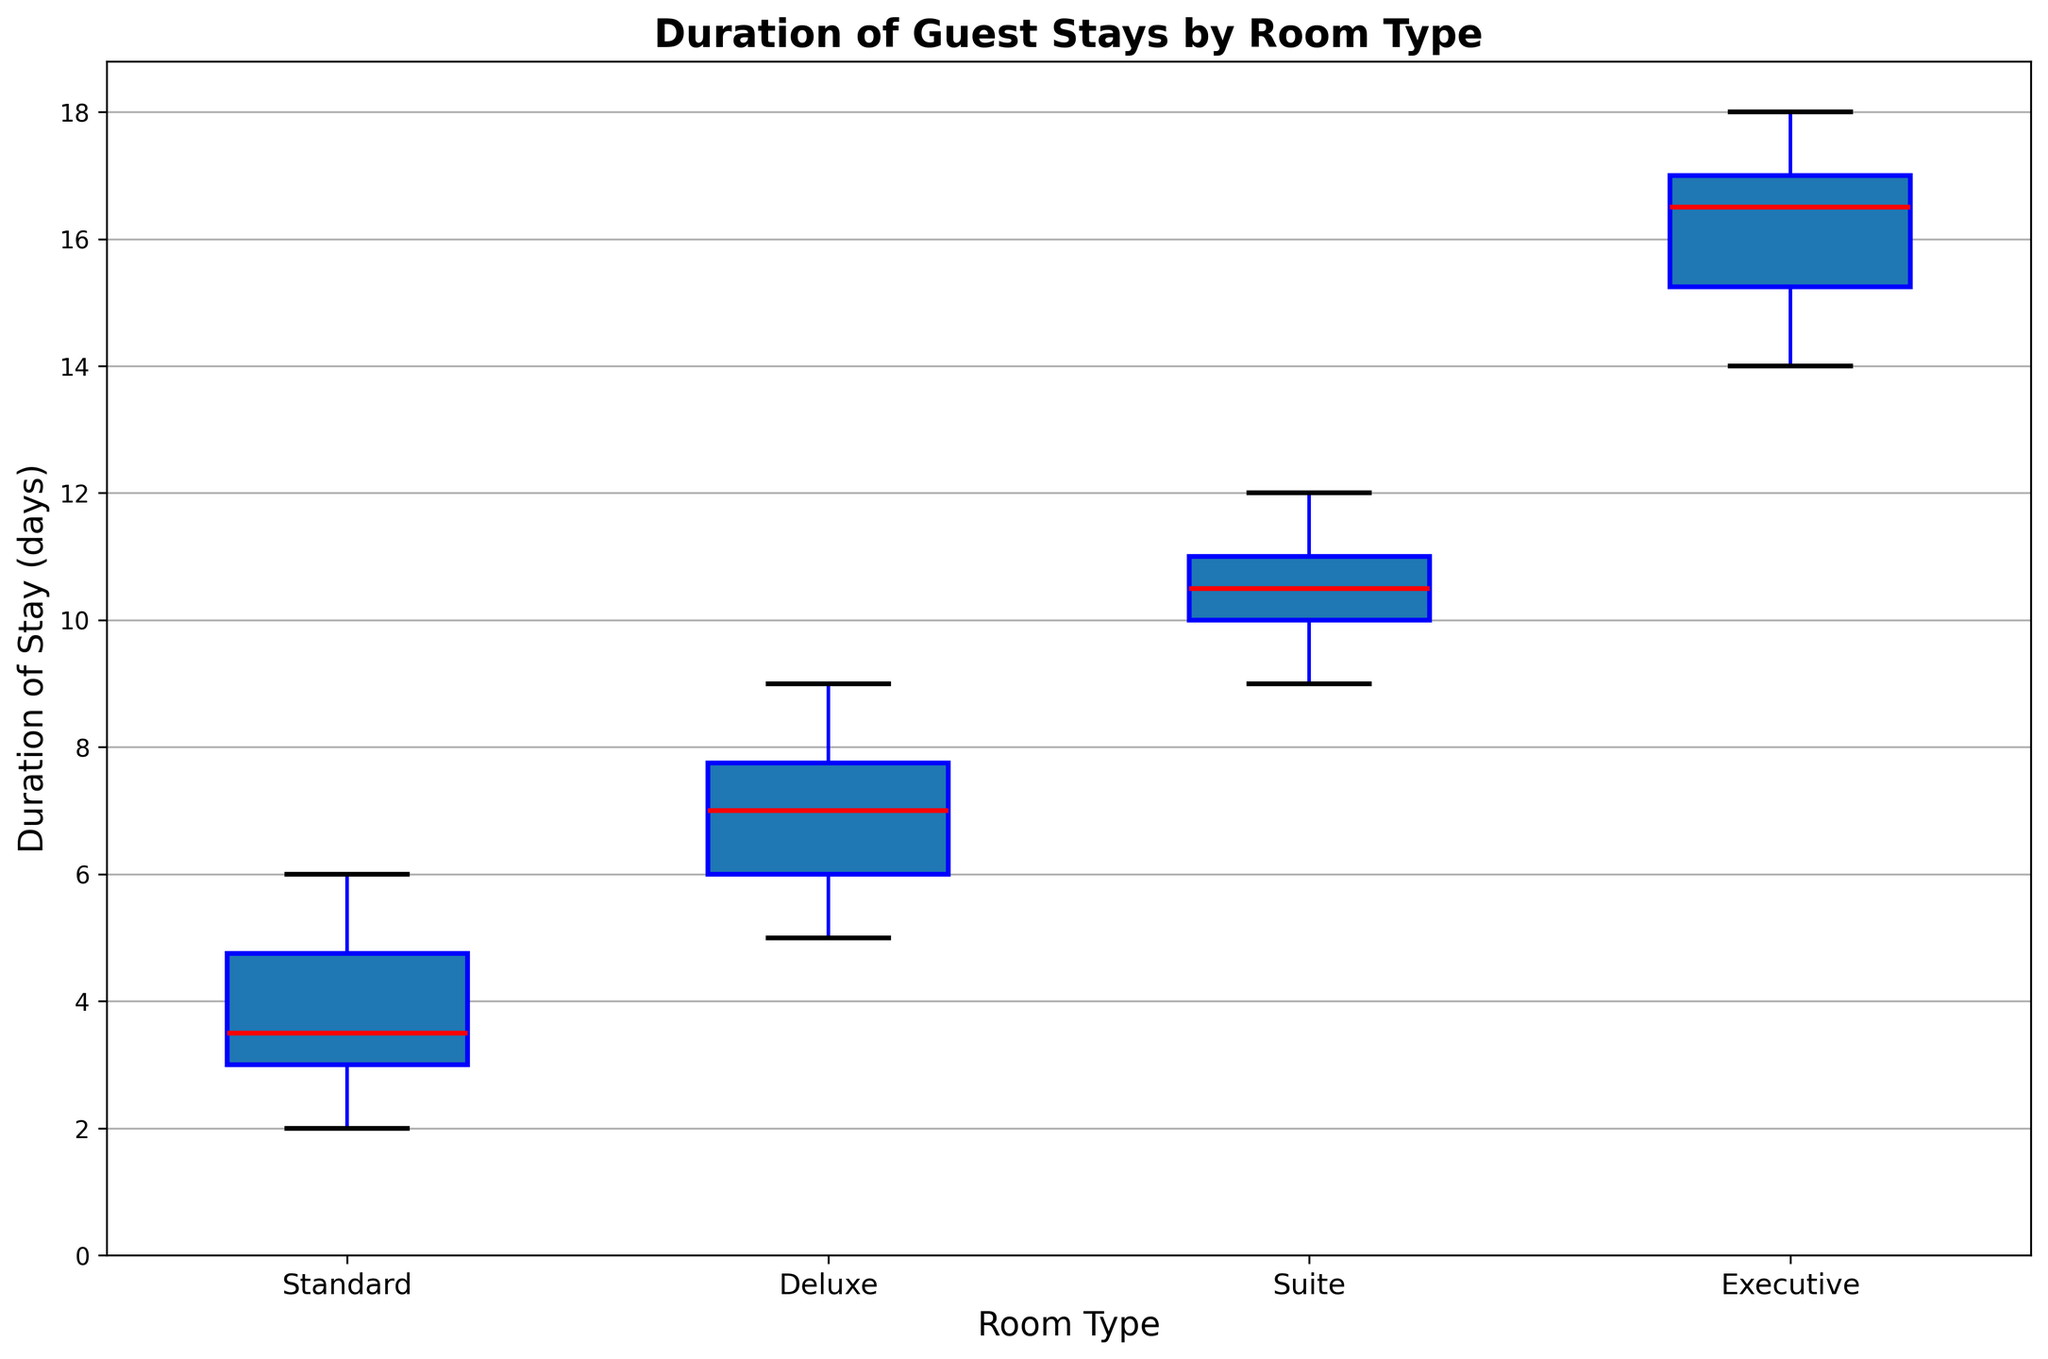Which room type has the highest median duration of stay? The median is represented by the red line in the middle of each box. The highest median line is in the Executive room type.
Answer: Executive What is the range of durations of stay for the Standard room type? The range is the difference between the maximum and minimum values. For Standard rooms, the whiskers extend from 2 to 6 days. So, 6 - 2 = 4 days.
Answer: 4 days Which room type has the smallest interquartile range (IQR) for the duration of stay? The IQR is the length of the box, representing the middle 50% of the data. By visually comparing the lengths of all boxes, the Standard room type has the smallest IQR.
Answer: Standard What is the most common duration of stay for the Deluxe room type? The most common value is the red line (the median). For the Deluxe rooms, it is at 7 days.
Answer: 7 days Which room type has the widest spread of guest stay durations? The widest spread can be seen through the length of the whiskers plus the height of the box. The Executive room type has the widest spread, from 14 to 18 days.
Answer: Executive How many room types have outliers? Outliers are represented by green circles. Looking at the plot, there are no green circles for any room type.
Answer: 0 Which room type has the highest upper whisker? The upper whisker is the top line extending from the box. The Executive room type's whisker reaches the highest, at 18 days.
Answer: Executive What is the difference between the median stay durations of Suite and Deluxe room types? The median for Suite is at 10.5 days and for Deluxe it is at 7 days. The difference is 10.5 - 7 = 3.5 days.
Answer: 3.5 days In which room types does the median duration of stay exceed 6 days? The red line denotes the median. By observing the boxes, the Deluxe, Suite, and Executive room types all have medians above 6 days.
Answer: Deluxe, Suite, Executive For the Standard room type, what is the mean of the upper and lower quartiles? The upper quartile (Q3) is the top edge of the box and the lower quartile (Q1) is the bottom edge. For Standard, Q3 is at 5 days and Q1 is at 3 days. The mean is (5 + 3) / 2 = 4 days.
Answer: 4 days 